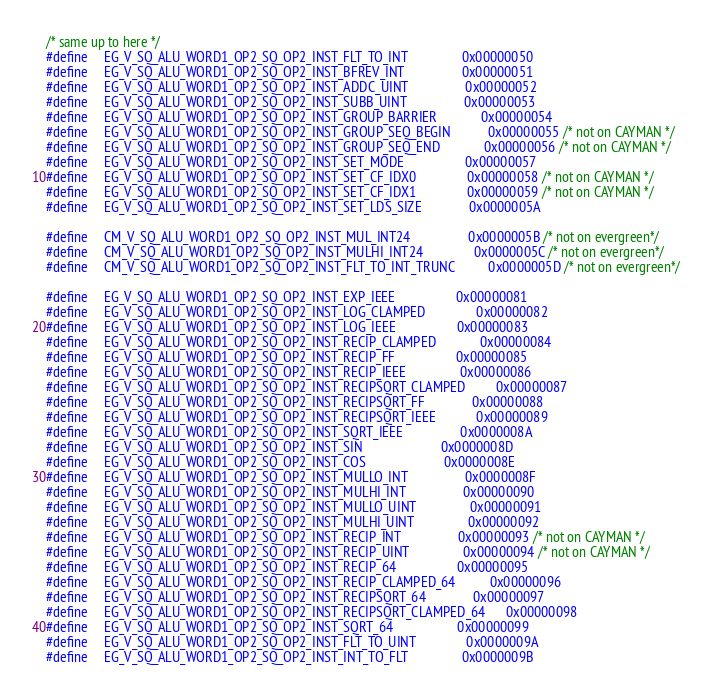<code> <loc_0><loc_0><loc_500><loc_500><_C++_>/* same up to here */
#define     EG_V_SQ_ALU_WORD1_OP2_SQ_OP2_INST_FLT_TO_INT                0x00000050
#define     EG_V_SQ_ALU_WORD1_OP2_SQ_OP2_INST_BFREV_INT                 0x00000051
#define     EG_V_SQ_ALU_WORD1_OP2_SQ_OP2_INST_ADDC_UINT                 0x00000052
#define     EG_V_SQ_ALU_WORD1_OP2_SQ_OP2_INST_SUBB_UINT                 0x00000053
#define     EG_V_SQ_ALU_WORD1_OP2_SQ_OP2_INST_GROUP_BARRIER             0x00000054
#define     EG_V_SQ_ALU_WORD1_OP2_SQ_OP2_INST_GROUP_SEQ_BEGIN           0x00000055 /* not on CAYMAN */
#define     EG_V_SQ_ALU_WORD1_OP2_SQ_OP2_INST_GROUP_SEQ_END             0x00000056 /* not on CAYMAN */
#define     EG_V_SQ_ALU_WORD1_OP2_SQ_OP2_INST_SET_MODE                  0x00000057
#define     EG_V_SQ_ALU_WORD1_OP2_SQ_OP2_INST_SET_CF_IDX0               0x00000058 /* not on CAYMAN */
#define     EG_V_SQ_ALU_WORD1_OP2_SQ_OP2_INST_SET_CF_IDX1               0x00000059 /* not on CAYMAN */
#define     EG_V_SQ_ALU_WORD1_OP2_SQ_OP2_INST_SET_LDS_SIZE              0x0000005A

#define     CM_V_SQ_ALU_WORD1_OP2_SQ_OP2_INST_MUL_INT24                 0x0000005B /* not on evergreen*/
#define     CM_V_SQ_ALU_WORD1_OP2_SQ_OP2_INST_MULHI_INT24               0x0000005C /* not on evergreen*/
#define     CM_V_SQ_ALU_WORD1_OP2_SQ_OP2_INST_FLT_TO_INT_TRUNC          0x0000005D /* not on evergreen*/

#define     EG_V_SQ_ALU_WORD1_OP2_SQ_OP2_INST_EXP_IEEE                  0x00000081
#define     EG_V_SQ_ALU_WORD1_OP2_SQ_OP2_INST_LOG_CLAMPED               0x00000082
#define     EG_V_SQ_ALU_WORD1_OP2_SQ_OP2_INST_LOG_IEEE                  0x00000083
#define     EG_V_SQ_ALU_WORD1_OP2_SQ_OP2_INST_RECIP_CLAMPED             0x00000084
#define     EG_V_SQ_ALU_WORD1_OP2_SQ_OP2_INST_RECIP_FF                  0x00000085
#define     EG_V_SQ_ALU_WORD1_OP2_SQ_OP2_INST_RECIP_IEEE                0x00000086
#define     EG_V_SQ_ALU_WORD1_OP2_SQ_OP2_INST_RECIPSQRT_CLAMPED         0x00000087
#define     EG_V_SQ_ALU_WORD1_OP2_SQ_OP2_INST_RECIPSQRT_FF              0x00000088
#define     EG_V_SQ_ALU_WORD1_OP2_SQ_OP2_INST_RECIPSQRT_IEEE            0x00000089
#define     EG_V_SQ_ALU_WORD1_OP2_SQ_OP2_INST_SQRT_IEEE                 0x0000008A
#define     EG_V_SQ_ALU_WORD1_OP2_SQ_OP2_INST_SIN                       0x0000008D
#define     EG_V_SQ_ALU_WORD1_OP2_SQ_OP2_INST_COS                       0x0000008E
#define     EG_V_SQ_ALU_WORD1_OP2_SQ_OP2_INST_MULLO_INT                 0x0000008F
#define     EG_V_SQ_ALU_WORD1_OP2_SQ_OP2_INST_MULHI_INT                 0x00000090
#define     EG_V_SQ_ALU_WORD1_OP2_SQ_OP2_INST_MULLO_UINT                0x00000091
#define     EG_V_SQ_ALU_WORD1_OP2_SQ_OP2_INST_MULHI_UINT                0x00000092
#define     EG_V_SQ_ALU_WORD1_OP2_SQ_OP2_INST_RECIP_INT                 0x00000093 /* not on CAYMAN */
#define     EG_V_SQ_ALU_WORD1_OP2_SQ_OP2_INST_RECIP_UINT                0x00000094 /* not on CAYMAN */
#define     EG_V_SQ_ALU_WORD1_OP2_SQ_OP2_INST_RECIP_64                  0x00000095
#define     EG_V_SQ_ALU_WORD1_OP2_SQ_OP2_INST_RECIP_CLAMPED_64          0x00000096
#define     EG_V_SQ_ALU_WORD1_OP2_SQ_OP2_INST_RECIPSQRT_64              0x00000097
#define     EG_V_SQ_ALU_WORD1_OP2_SQ_OP2_INST_RECIPSQRT_CLAMPED_64      0x00000098
#define     EG_V_SQ_ALU_WORD1_OP2_SQ_OP2_INST_SQRT_64                   0x00000099
#define     EG_V_SQ_ALU_WORD1_OP2_SQ_OP2_INST_FLT_TO_UINT               0x0000009A
#define     EG_V_SQ_ALU_WORD1_OP2_SQ_OP2_INST_INT_TO_FLT                0x0000009B</code> 